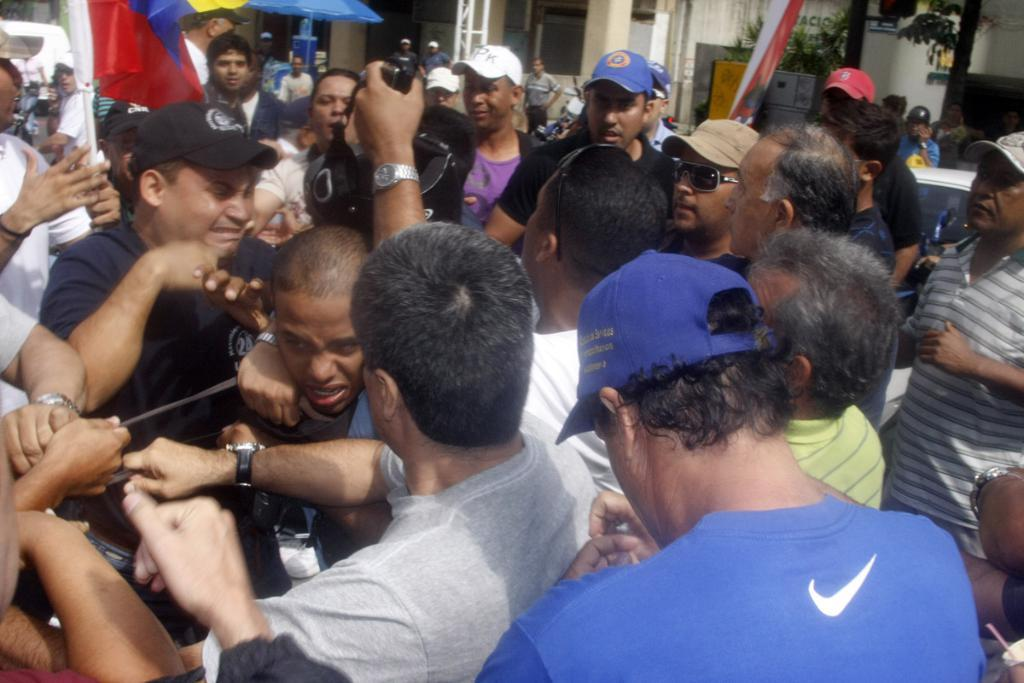How many people are in the group visible in the image? There is a group of people in the image, but the exact number is not specified. What are some people in the group wearing? Some people in the group are wearing caps. What can be seen in the background of the image? In the background of the image, there is a car, metal rods, flags, trees, and houses. Can you describe the setting of the image? The image appears to be outdoors, with a group of people, a car, and various objects and structures in the background. What book is the person reading in the image? There is no person reading a book in the image. What is the income of the person holding the flag in the image? There is no information about the income of any person in the image. 